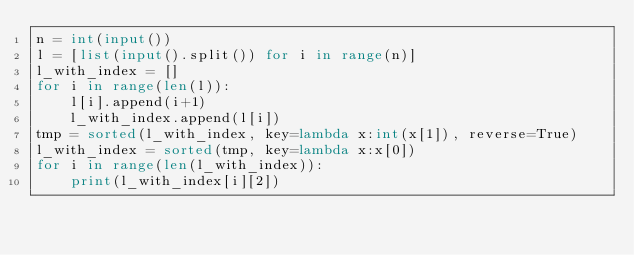<code> <loc_0><loc_0><loc_500><loc_500><_Python_>n = int(input())
l = [list(input().split()) for i in range(n)]
l_with_index = []
for i in range(len(l)):
    l[i].append(i+1)
    l_with_index.append(l[i])
tmp = sorted(l_with_index, key=lambda x:int(x[1]), reverse=True)
l_with_index = sorted(tmp, key=lambda x:x[0])
for i in range(len(l_with_index)):
    print(l_with_index[i][2])</code> 